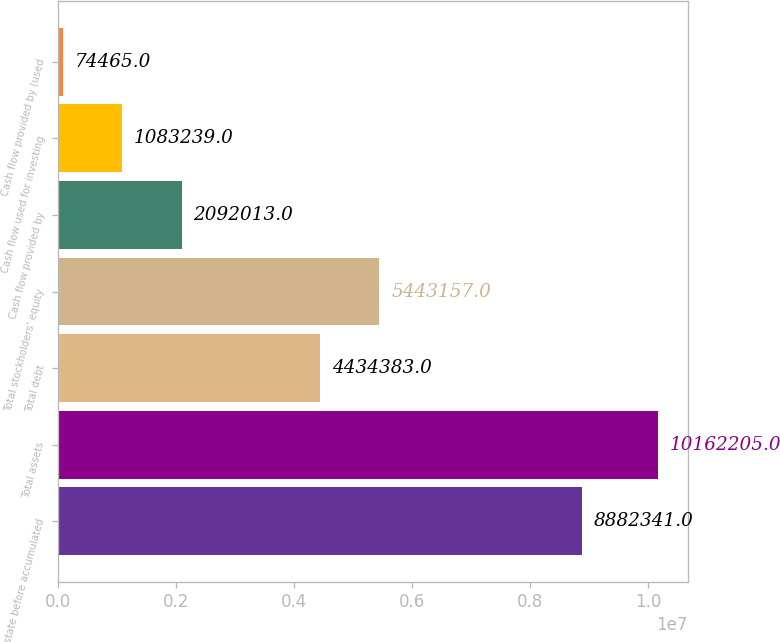Convert chart to OTSL. <chart><loc_0><loc_0><loc_500><loc_500><bar_chart><fcel>Real estate before accumulated<fcel>Total assets<fcel>Total debt<fcel>Total stockholders' equity<fcel>Cash flow provided by<fcel>Cash flow used for investing<fcel>Cash flow provided by (used<nl><fcel>8.88234e+06<fcel>1.01622e+07<fcel>4.43438e+06<fcel>5.44316e+06<fcel>2.09201e+06<fcel>1.08324e+06<fcel>74465<nl></chart> 